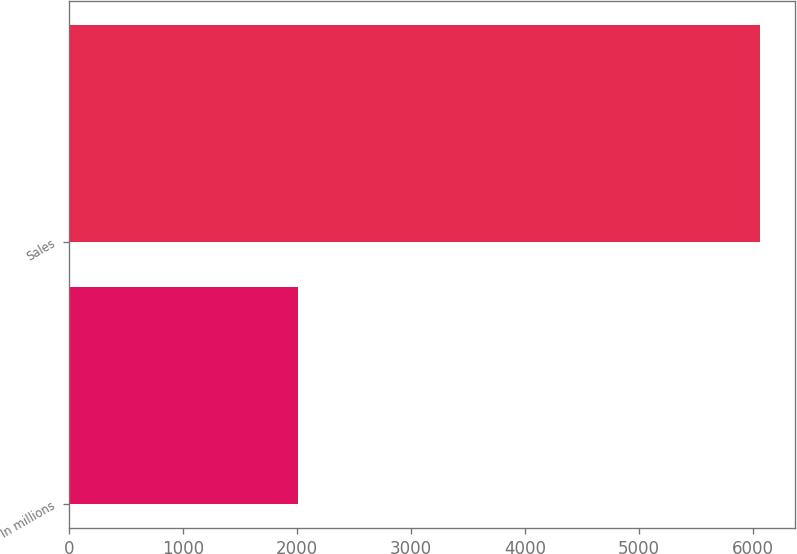<chart> <loc_0><loc_0><loc_500><loc_500><bar_chart><fcel>In millions<fcel>Sales<nl><fcel>2004<fcel>6065<nl></chart> 